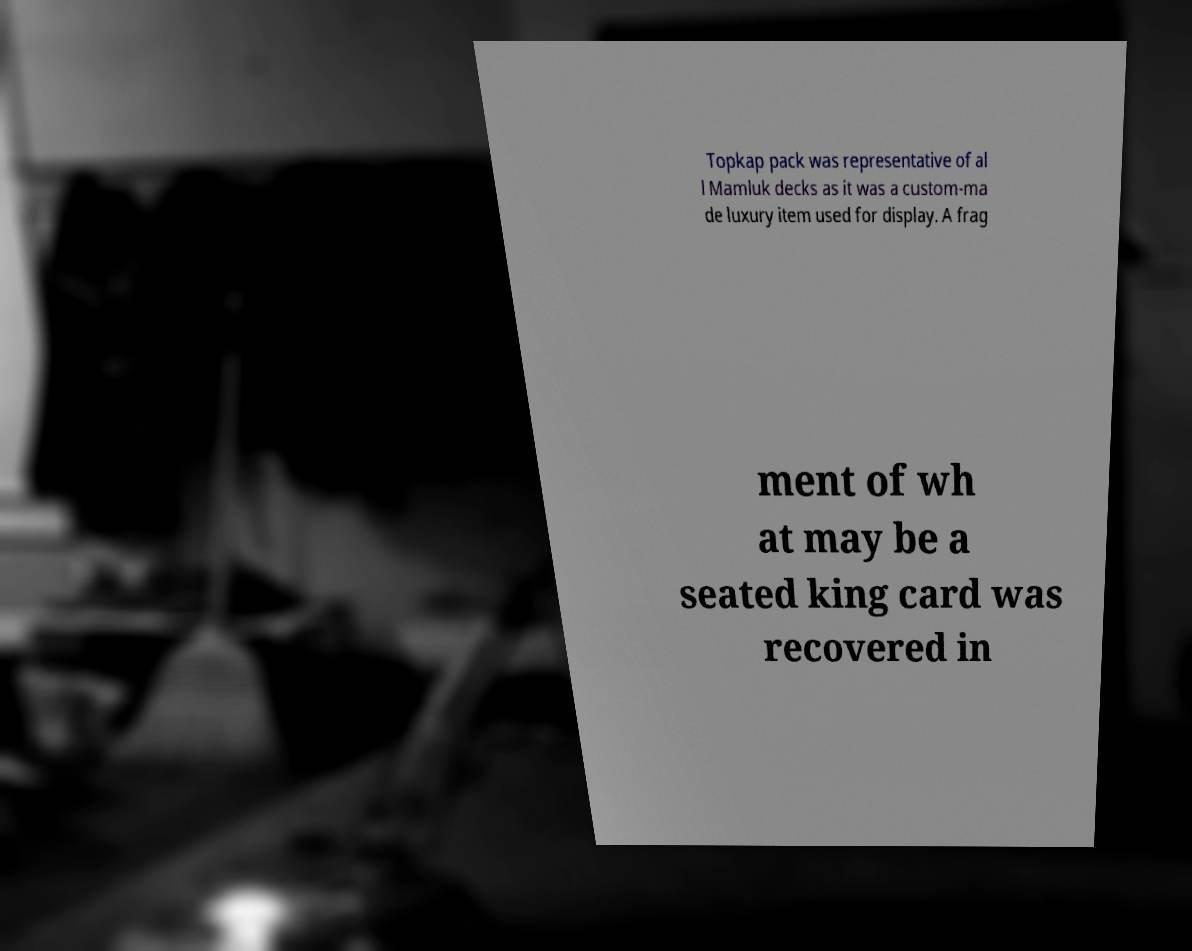Can you read and provide the text displayed in the image?This photo seems to have some interesting text. Can you extract and type it out for me? Topkap pack was representative of al l Mamluk decks as it was a custom-ma de luxury item used for display. A frag ment of wh at may be a seated king card was recovered in 